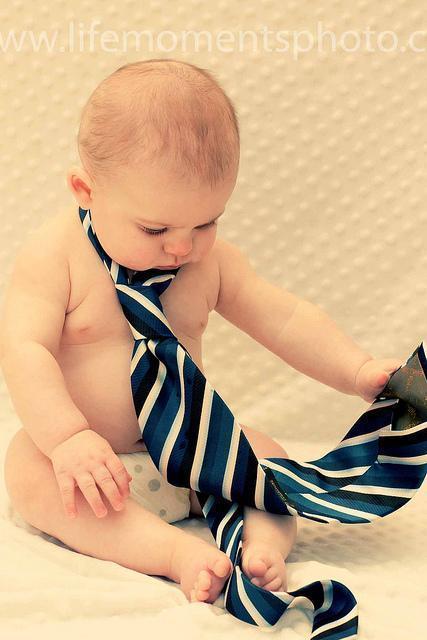How many giraffes are there?
Give a very brief answer. 0. 